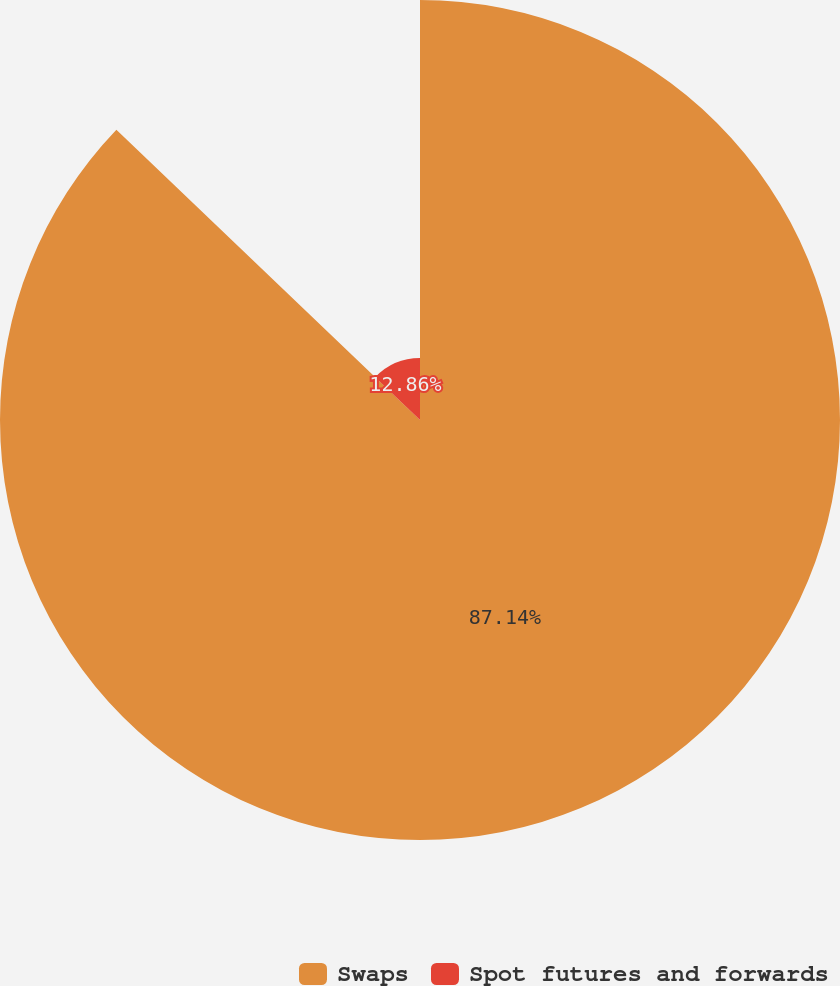Convert chart. <chart><loc_0><loc_0><loc_500><loc_500><pie_chart><fcel>Swaps<fcel>Spot futures and forwards<nl><fcel>87.14%<fcel>12.86%<nl></chart> 